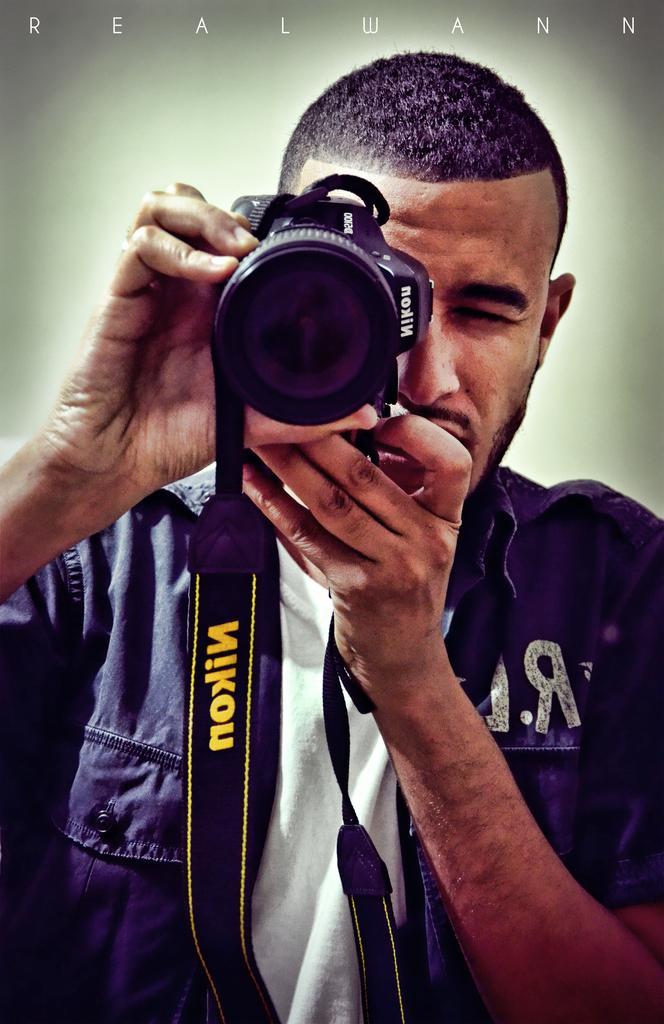In one or two sentences, can you explain what this image depicts? In this picture there is a man holding a camera in his hand. 